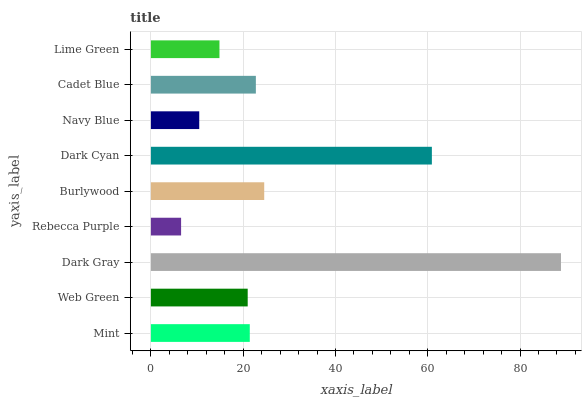Is Rebecca Purple the minimum?
Answer yes or no. Yes. Is Dark Gray the maximum?
Answer yes or no. Yes. Is Web Green the minimum?
Answer yes or no. No. Is Web Green the maximum?
Answer yes or no. No. Is Mint greater than Web Green?
Answer yes or no. Yes. Is Web Green less than Mint?
Answer yes or no. Yes. Is Web Green greater than Mint?
Answer yes or no. No. Is Mint less than Web Green?
Answer yes or no. No. Is Mint the high median?
Answer yes or no. Yes. Is Mint the low median?
Answer yes or no. Yes. Is Navy Blue the high median?
Answer yes or no. No. Is Dark Cyan the low median?
Answer yes or no. No. 